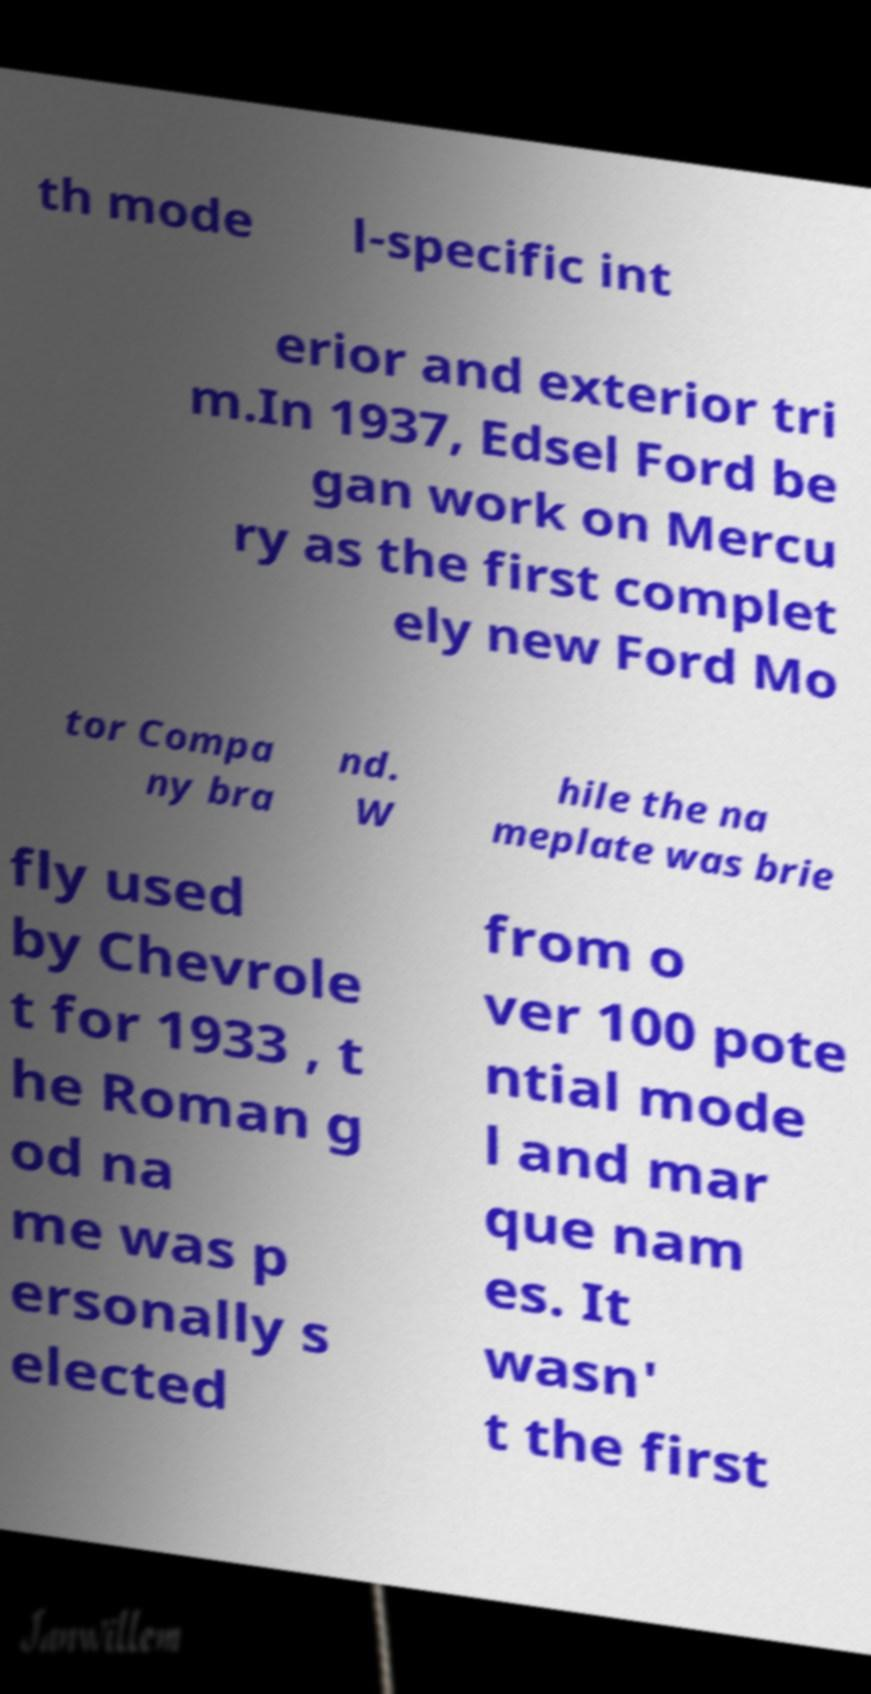Please identify and transcribe the text found in this image. th mode l-specific int erior and exterior tri m.In 1937, Edsel Ford be gan work on Mercu ry as the first complet ely new Ford Mo tor Compa ny bra nd. W hile the na meplate was brie fly used by Chevrole t for 1933 , t he Roman g od na me was p ersonally s elected from o ver 100 pote ntial mode l and mar que nam es. It wasn' t the first 